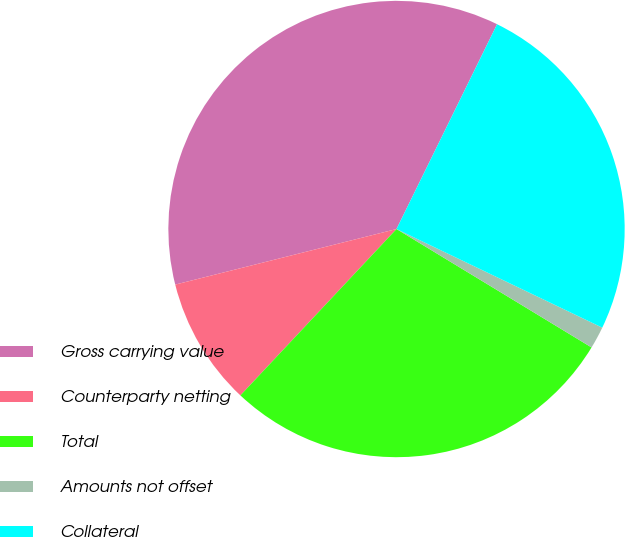<chart> <loc_0><loc_0><loc_500><loc_500><pie_chart><fcel>Gross carrying value<fcel>Counterparty netting<fcel>Total<fcel>Amounts not offset<fcel>Collateral<nl><fcel>36.18%<fcel>9.09%<fcel>28.31%<fcel>1.57%<fcel>24.85%<nl></chart> 